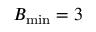Convert formula to latex. <formula><loc_0><loc_0><loc_500><loc_500>B _ { \min } = 3</formula> 